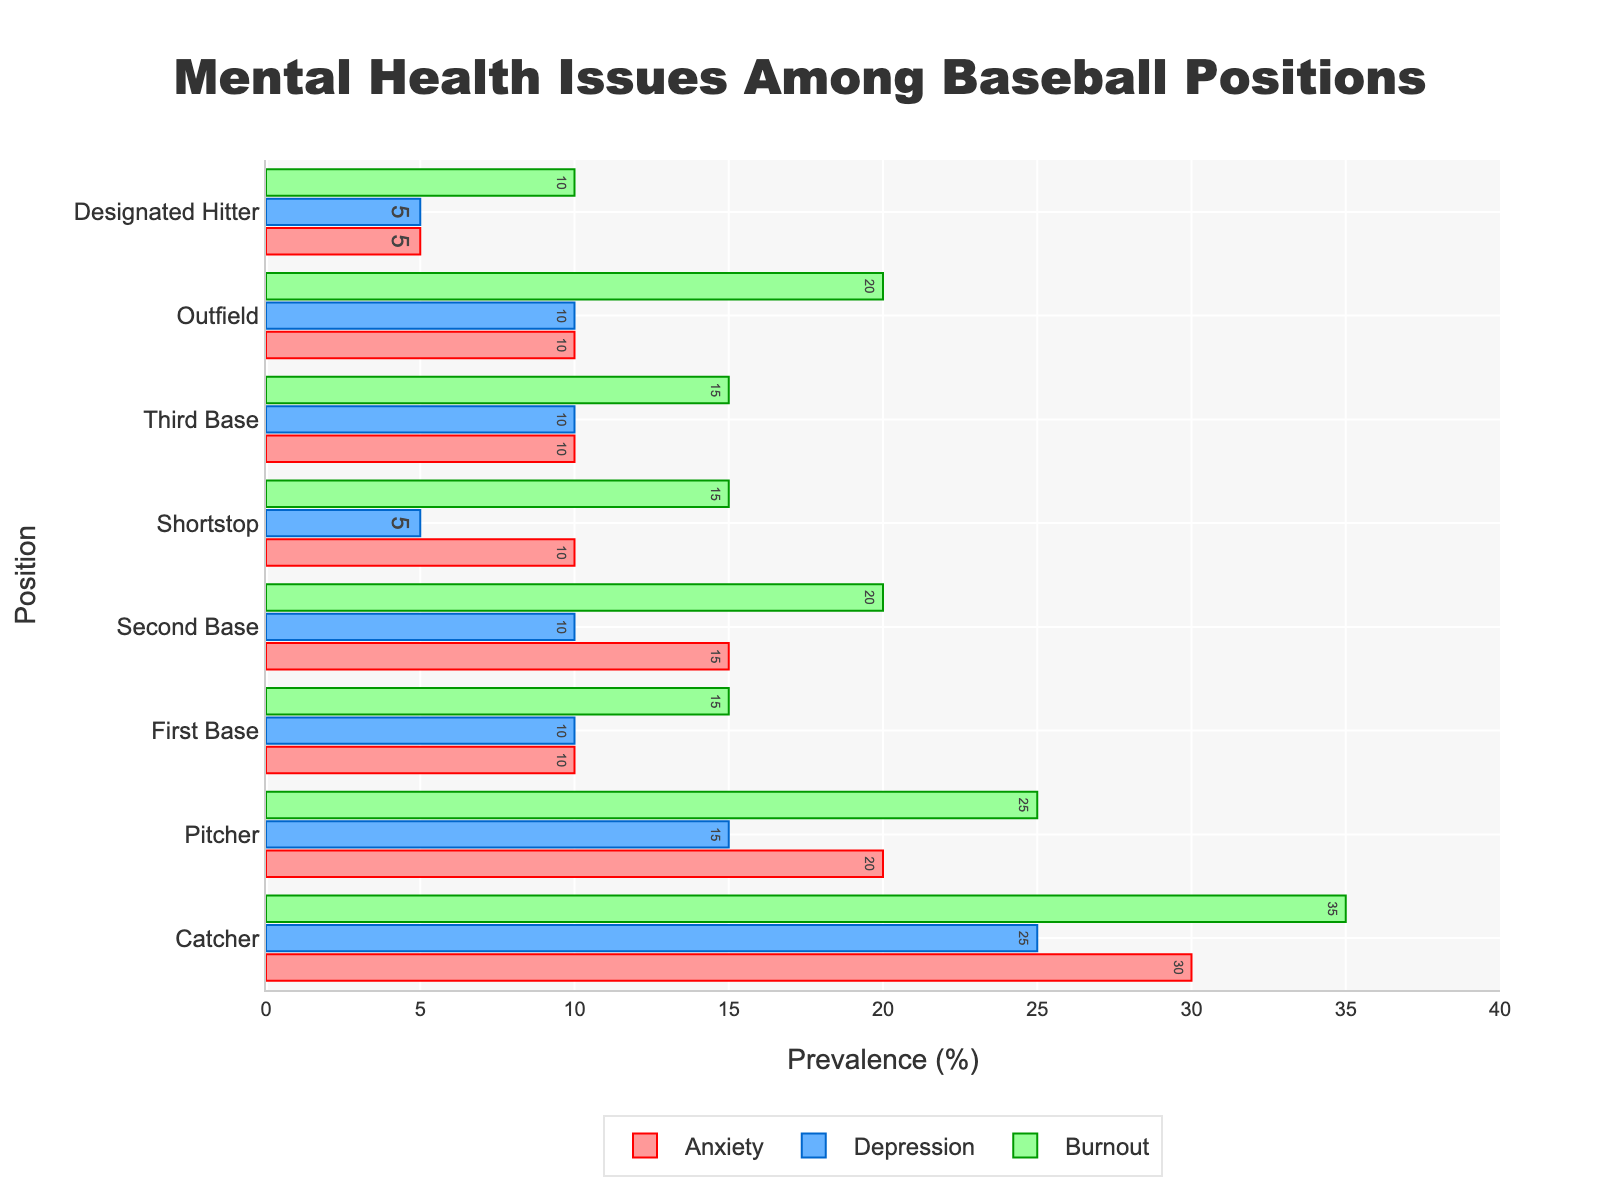what position has the highest level of anxiety reported? From the figure, observe the red bars which represent anxiety levels. The longest red bar corresponds to the catcher position.
Answer: Catcher Which position has the lowest percentage of depression? Look at the blue bars that indicate depression percentages. The shortest blue bar is for the designated hitter position.
Answer: Designated Hitter Compare the burnout levels between the catcher and the outfield positions. Which one is higher? By comparing the green bars, notice that the catcher has a longer green bar compared to the outfield, indicating a higher burnout level.
Answer: Catcher What is the average percentage of mental health issues (anxiety, depression, and burnout) for the second base position? Sum the values for anxiety (15), depression (10), and burnout (20) then divide by 3: (15+10+20)/3 = 15.
Answer: 15 How much higher is the anxiety level among catchers compared to first base players? Subtract the anxiety level of first base (10) from the anxiety level of catchers (30): 30 - 10 = 20.
Answer: 20 Which position has the same percentage for both depression and anxiety? Referencing the bars for depression and anxiety, the first base and outfield positions both have equal values of 10% for both mental health issues.
Answer: First Base, Outfield How does the prevalence of burnout among pitchers compare to that of shortstops? The green bar for pitchers and shortstops should be compared. The burnout rate for pitchers is 25%, whereas for shortstops, it is 15%. Therefore, pitchers have a higher burnout level.
Answer: Pitchers Identify the position with the highest combined mental health issues (sum of anxiety, depression, and burnout). Calculate the sum for each position: 
Catcher (30+25+35 = 90), Pitcher (20+15+25 = 60), First Base (10+10+15 = 35), Second Base (15+10+20 = 45), Shortstop (10+5+15 = 30), Third Base (10+10+15 = 35), Outfield (10+10+20 = 40), Designated Hitter (5+5+10 = 20). The catcher has the highest combined value of 90.
Answer: Catcher What is the difference in depression levels between the shortstop and third base positions? The blue bar for shortstops is 5%, and for third base, it is 10%. The difference is 10 - 5 = 5.
Answer: 5 What is the median value of burnout percentages across all positions? Arrange burnout percentages in ascending order: 10, 15, 15, 15, 20, 20, 25, 35. The median value is the average of the 4th and 5th values: (15+20)/2 = 17.5.
Answer: 17.5 